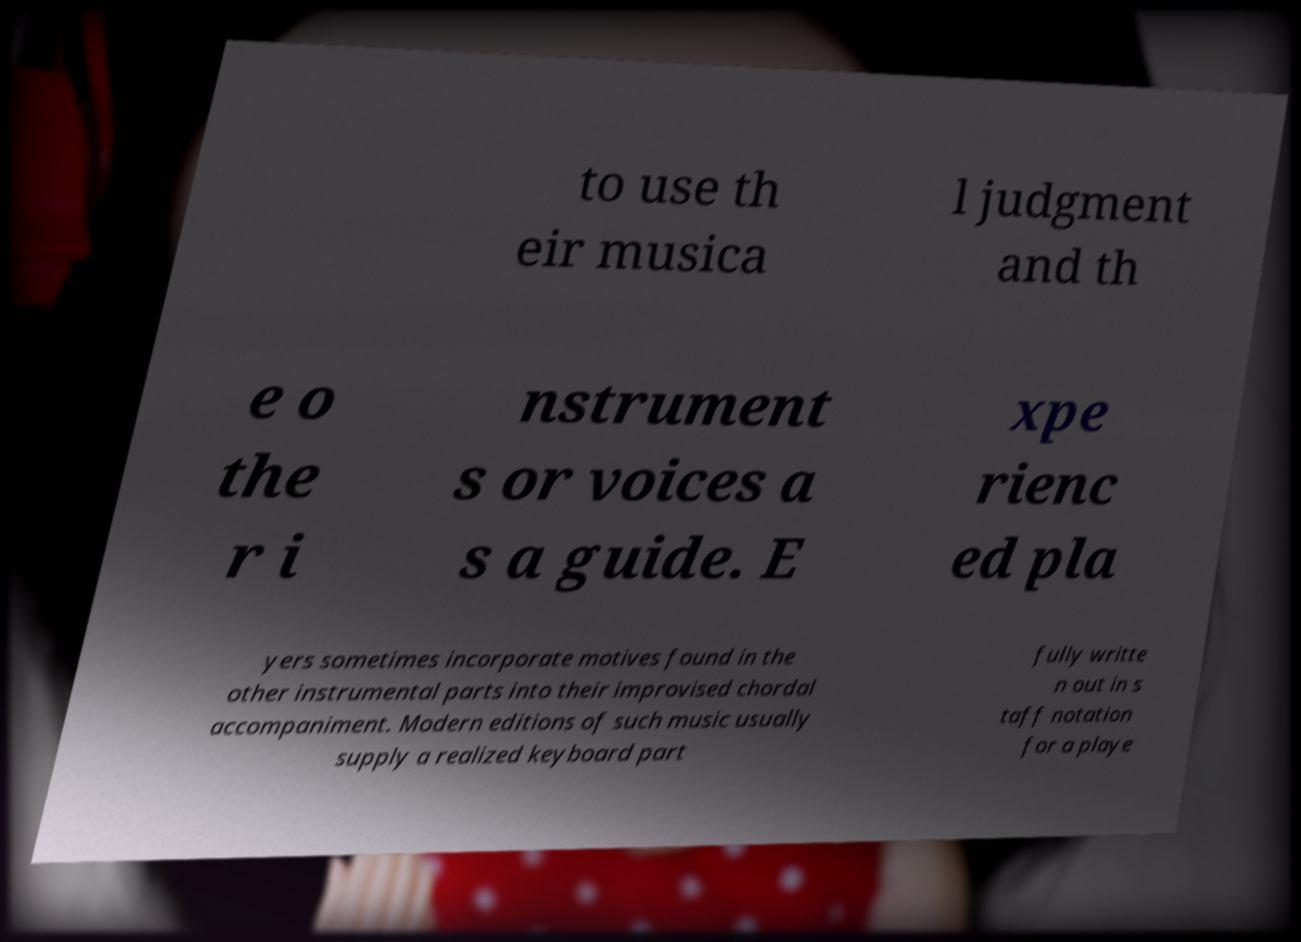There's text embedded in this image that I need extracted. Can you transcribe it verbatim? to use th eir musica l judgment and th e o the r i nstrument s or voices a s a guide. E xpe rienc ed pla yers sometimes incorporate motives found in the other instrumental parts into their improvised chordal accompaniment. Modern editions of such music usually supply a realized keyboard part fully writte n out in s taff notation for a playe 